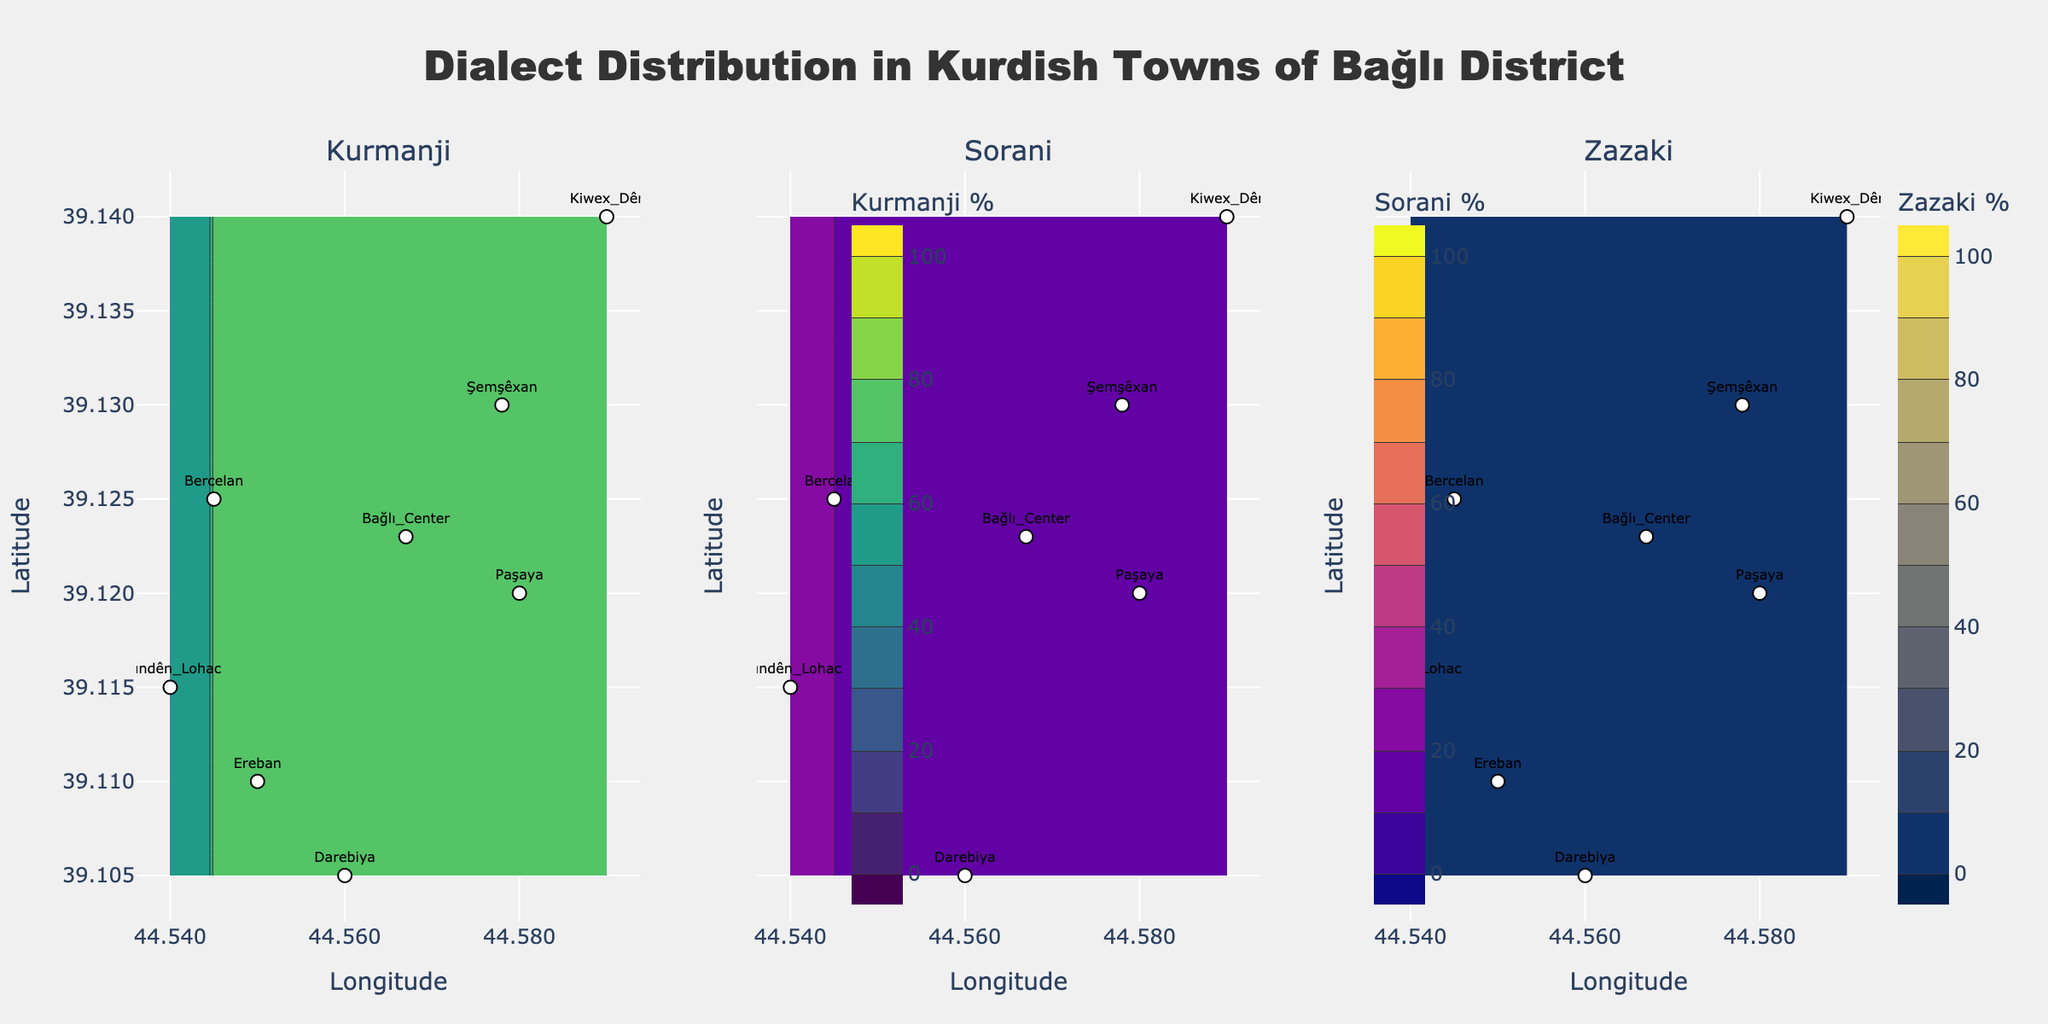Which town has the highest percentage of Kurmanji speakers? By looking at the Kurmanji contour plot, the town with the darkest green shades represents the highest percentage of Kurmanji speakers. Then, cross-reference this with the labels for confirmation.
Answer: Paşaya What is the approximate percentage of Sorani speakers in Kiwex Dêr? Check the Sorani subplot and look at the contour lines and their labeled values over Kiwex Dêr. Identify the closest contour level lines and interpolate.
Answer: 40% Which dialect is most evenly distributed across the towns? Compare the uniformity of color shades across the towns in each subplot for Kurmanji, Sorani, and Zazaki. The dialect with the least variation in shades is the most evenly distributed.
Answer: Zazaki How do the percentages of Sorani speakers in Darebiya and Ereban compare? Identify Darebiya and Ereban on the Sorani subplot, check the contour lines crossing each town, and compare the percentage values.
Answer: Darebiya has more Sorani speakers What percentage of Kurmanji speakers is there in Bağlı Center? Locate Bağlı Center in the Kurmanji subplot and find the contour level value corresponding to that location.
Answer: 60% Which town shows the highest diversity in dialects? Examine each town across all three subplots (Kurmanji, Sorani, Zazaki) to find one that has significant values in all three dialects, suggesting diversity.
Answer: Kiwex Dêr What is the latitude range of the towns shown in the plots? Check the latitude values on the y-axis and identify the minimum and maximum values covered by the markers representing the towns.
Answer: 39.105 to 39.140 Between Paşaya and Bercelan, which town has a higher percentage of Sorani speakers? Compare the positions of Paşaya and Bercelan on the Sorani subplot and evaluate the contour lines or color gradients representing their Sorani percentages.
Answer: Bercelan 